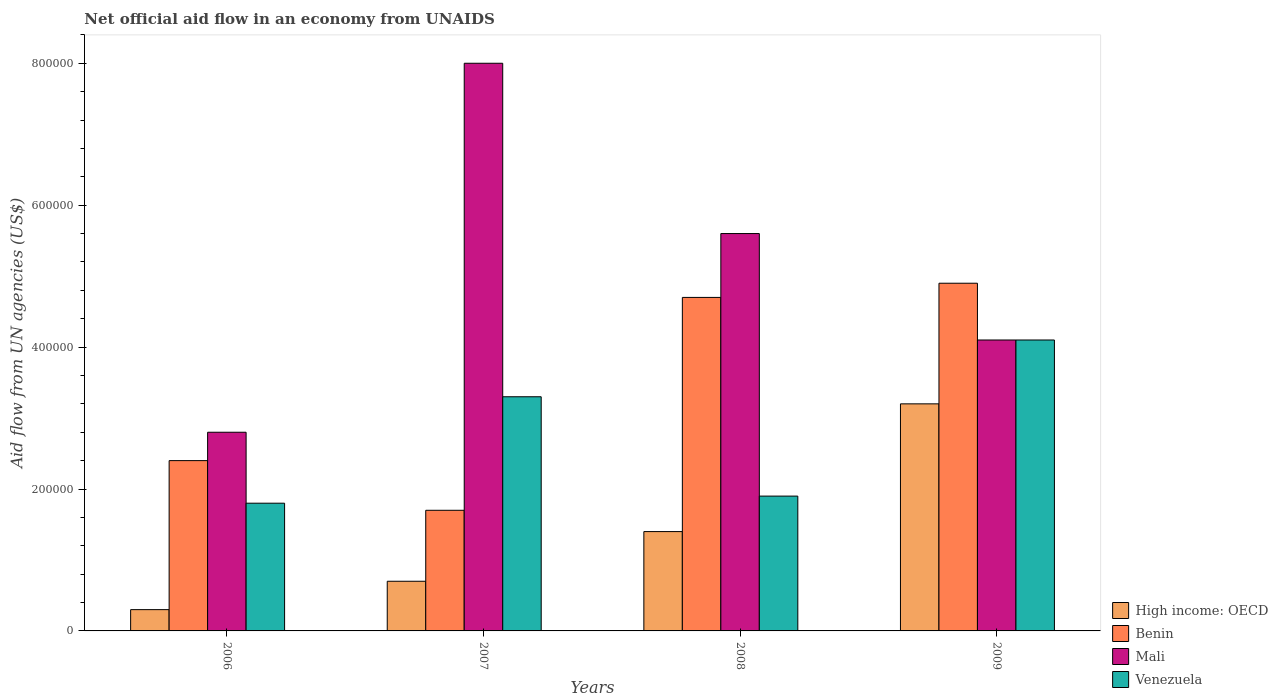How many groups of bars are there?
Keep it short and to the point. 4. Are the number of bars per tick equal to the number of legend labels?
Your answer should be very brief. Yes. How many bars are there on the 3rd tick from the left?
Provide a short and direct response. 4. What is the label of the 1st group of bars from the left?
Give a very brief answer. 2006. In how many cases, is the number of bars for a given year not equal to the number of legend labels?
Your response must be concise. 0. What is the net official aid flow in Venezuela in 2009?
Offer a terse response. 4.10e+05. Across all years, what is the maximum net official aid flow in Venezuela?
Your response must be concise. 4.10e+05. Across all years, what is the minimum net official aid flow in Mali?
Provide a succinct answer. 2.80e+05. In which year was the net official aid flow in Benin maximum?
Give a very brief answer. 2009. In which year was the net official aid flow in Mali minimum?
Make the answer very short. 2006. What is the total net official aid flow in Mali in the graph?
Ensure brevity in your answer.  2.05e+06. What is the difference between the net official aid flow in Benin in 2006 and that in 2009?
Your answer should be very brief. -2.50e+05. What is the difference between the net official aid flow in High income: OECD in 2008 and the net official aid flow in Mali in 2009?
Give a very brief answer. -2.70e+05. What is the average net official aid flow in Venezuela per year?
Offer a very short reply. 2.78e+05. In the year 2009, what is the difference between the net official aid flow in High income: OECD and net official aid flow in Mali?
Ensure brevity in your answer.  -9.00e+04. In how many years, is the net official aid flow in Benin greater than 520000 US$?
Provide a succinct answer. 0. What is the ratio of the net official aid flow in High income: OECD in 2006 to that in 2008?
Give a very brief answer. 0.21. Is the net official aid flow in Venezuela in 2008 less than that in 2009?
Your response must be concise. Yes. What is the difference between the highest and the lowest net official aid flow in High income: OECD?
Provide a succinct answer. 2.90e+05. What does the 4th bar from the left in 2009 represents?
Your answer should be compact. Venezuela. What does the 3rd bar from the right in 2007 represents?
Keep it short and to the point. Benin. Is it the case that in every year, the sum of the net official aid flow in Venezuela and net official aid flow in Mali is greater than the net official aid flow in High income: OECD?
Your answer should be very brief. Yes. What is the difference between two consecutive major ticks on the Y-axis?
Your response must be concise. 2.00e+05. Are the values on the major ticks of Y-axis written in scientific E-notation?
Provide a succinct answer. No. Does the graph contain any zero values?
Keep it short and to the point. No. Where does the legend appear in the graph?
Provide a short and direct response. Bottom right. What is the title of the graph?
Provide a short and direct response. Net official aid flow in an economy from UNAIDS. What is the label or title of the Y-axis?
Offer a very short reply. Aid flow from UN agencies (US$). What is the Aid flow from UN agencies (US$) in Mali in 2006?
Your answer should be very brief. 2.80e+05. What is the Aid flow from UN agencies (US$) of Venezuela in 2006?
Offer a very short reply. 1.80e+05. What is the Aid flow from UN agencies (US$) in High income: OECD in 2007?
Your answer should be compact. 7.00e+04. What is the Aid flow from UN agencies (US$) in Mali in 2007?
Your answer should be very brief. 8.00e+05. What is the Aid flow from UN agencies (US$) of Benin in 2008?
Give a very brief answer. 4.70e+05. What is the Aid flow from UN agencies (US$) in Mali in 2008?
Provide a short and direct response. 5.60e+05. What is the Aid flow from UN agencies (US$) in High income: OECD in 2009?
Keep it short and to the point. 3.20e+05. What is the Aid flow from UN agencies (US$) in Venezuela in 2009?
Provide a short and direct response. 4.10e+05. Across all years, what is the maximum Aid flow from UN agencies (US$) of Benin?
Provide a short and direct response. 4.90e+05. Across all years, what is the minimum Aid flow from UN agencies (US$) in Benin?
Your answer should be compact. 1.70e+05. Across all years, what is the minimum Aid flow from UN agencies (US$) in Mali?
Offer a very short reply. 2.80e+05. What is the total Aid flow from UN agencies (US$) in High income: OECD in the graph?
Provide a succinct answer. 5.60e+05. What is the total Aid flow from UN agencies (US$) in Benin in the graph?
Your answer should be compact. 1.37e+06. What is the total Aid flow from UN agencies (US$) of Mali in the graph?
Provide a short and direct response. 2.05e+06. What is the total Aid flow from UN agencies (US$) of Venezuela in the graph?
Provide a succinct answer. 1.11e+06. What is the difference between the Aid flow from UN agencies (US$) of Mali in 2006 and that in 2007?
Ensure brevity in your answer.  -5.20e+05. What is the difference between the Aid flow from UN agencies (US$) in Benin in 2006 and that in 2008?
Your answer should be very brief. -2.30e+05. What is the difference between the Aid flow from UN agencies (US$) of Mali in 2006 and that in 2008?
Offer a very short reply. -2.80e+05. What is the difference between the Aid flow from UN agencies (US$) in High income: OECD in 2006 and that in 2009?
Ensure brevity in your answer.  -2.90e+05. What is the difference between the Aid flow from UN agencies (US$) in Benin in 2006 and that in 2009?
Your answer should be very brief. -2.50e+05. What is the difference between the Aid flow from UN agencies (US$) of Venezuela in 2007 and that in 2008?
Give a very brief answer. 1.40e+05. What is the difference between the Aid flow from UN agencies (US$) in High income: OECD in 2007 and that in 2009?
Provide a succinct answer. -2.50e+05. What is the difference between the Aid flow from UN agencies (US$) in Benin in 2007 and that in 2009?
Offer a very short reply. -3.20e+05. What is the difference between the Aid flow from UN agencies (US$) in High income: OECD in 2008 and that in 2009?
Your response must be concise. -1.80e+05. What is the difference between the Aid flow from UN agencies (US$) of Benin in 2008 and that in 2009?
Your answer should be very brief. -2.00e+04. What is the difference between the Aid flow from UN agencies (US$) of Venezuela in 2008 and that in 2009?
Offer a very short reply. -2.20e+05. What is the difference between the Aid flow from UN agencies (US$) in High income: OECD in 2006 and the Aid flow from UN agencies (US$) in Benin in 2007?
Ensure brevity in your answer.  -1.40e+05. What is the difference between the Aid flow from UN agencies (US$) of High income: OECD in 2006 and the Aid flow from UN agencies (US$) of Mali in 2007?
Your answer should be very brief. -7.70e+05. What is the difference between the Aid flow from UN agencies (US$) in Benin in 2006 and the Aid flow from UN agencies (US$) in Mali in 2007?
Provide a succinct answer. -5.60e+05. What is the difference between the Aid flow from UN agencies (US$) of High income: OECD in 2006 and the Aid flow from UN agencies (US$) of Benin in 2008?
Your answer should be compact. -4.40e+05. What is the difference between the Aid flow from UN agencies (US$) in High income: OECD in 2006 and the Aid flow from UN agencies (US$) in Mali in 2008?
Give a very brief answer. -5.30e+05. What is the difference between the Aid flow from UN agencies (US$) of Benin in 2006 and the Aid flow from UN agencies (US$) of Mali in 2008?
Provide a short and direct response. -3.20e+05. What is the difference between the Aid flow from UN agencies (US$) in Mali in 2006 and the Aid flow from UN agencies (US$) in Venezuela in 2008?
Your answer should be very brief. 9.00e+04. What is the difference between the Aid flow from UN agencies (US$) of High income: OECD in 2006 and the Aid flow from UN agencies (US$) of Benin in 2009?
Give a very brief answer. -4.60e+05. What is the difference between the Aid flow from UN agencies (US$) in High income: OECD in 2006 and the Aid flow from UN agencies (US$) in Mali in 2009?
Your response must be concise. -3.80e+05. What is the difference between the Aid flow from UN agencies (US$) in High income: OECD in 2006 and the Aid flow from UN agencies (US$) in Venezuela in 2009?
Keep it short and to the point. -3.80e+05. What is the difference between the Aid flow from UN agencies (US$) of Benin in 2006 and the Aid flow from UN agencies (US$) of Mali in 2009?
Keep it short and to the point. -1.70e+05. What is the difference between the Aid flow from UN agencies (US$) of High income: OECD in 2007 and the Aid flow from UN agencies (US$) of Benin in 2008?
Give a very brief answer. -4.00e+05. What is the difference between the Aid flow from UN agencies (US$) in High income: OECD in 2007 and the Aid flow from UN agencies (US$) in Mali in 2008?
Provide a short and direct response. -4.90e+05. What is the difference between the Aid flow from UN agencies (US$) in Benin in 2007 and the Aid flow from UN agencies (US$) in Mali in 2008?
Your answer should be very brief. -3.90e+05. What is the difference between the Aid flow from UN agencies (US$) in Mali in 2007 and the Aid flow from UN agencies (US$) in Venezuela in 2008?
Your response must be concise. 6.10e+05. What is the difference between the Aid flow from UN agencies (US$) in High income: OECD in 2007 and the Aid flow from UN agencies (US$) in Benin in 2009?
Your answer should be very brief. -4.20e+05. What is the difference between the Aid flow from UN agencies (US$) in High income: OECD in 2007 and the Aid flow from UN agencies (US$) in Venezuela in 2009?
Provide a succinct answer. -3.40e+05. What is the difference between the Aid flow from UN agencies (US$) of Mali in 2007 and the Aid flow from UN agencies (US$) of Venezuela in 2009?
Your answer should be very brief. 3.90e+05. What is the difference between the Aid flow from UN agencies (US$) of High income: OECD in 2008 and the Aid flow from UN agencies (US$) of Benin in 2009?
Your answer should be compact. -3.50e+05. What is the difference between the Aid flow from UN agencies (US$) of High income: OECD in 2008 and the Aid flow from UN agencies (US$) of Mali in 2009?
Your answer should be very brief. -2.70e+05. What is the difference between the Aid flow from UN agencies (US$) of High income: OECD in 2008 and the Aid flow from UN agencies (US$) of Venezuela in 2009?
Give a very brief answer. -2.70e+05. What is the difference between the Aid flow from UN agencies (US$) in Benin in 2008 and the Aid flow from UN agencies (US$) in Venezuela in 2009?
Provide a succinct answer. 6.00e+04. What is the average Aid flow from UN agencies (US$) in Benin per year?
Provide a short and direct response. 3.42e+05. What is the average Aid flow from UN agencies (US$) in Mali per year?
Make the answer very short. 5.12e+05. What is the average Aid flow from UN agencies (US$) of Venezuela per year?
Make the answer very short. 2.78e+05. In the year 2006, what is the difference between the Aid flow from UN agencies (US$) in High income: OECD and Aid flow from UN agencies (US$) in Mali?
Offer a very short reply. -2.50e+05. In the year 2006, what is the difference between the Aid flow from UN agencies (US$) in Benin and Aid flow from UN agencies (US$) in Mali?
Ensure brevity in your answer.  -4.00e+04. In the year 2006, what is the difference between the Aid flow from UN agencies (US$) of Benin and Aid flow from UN agencies (US$) of Venezuela?
Keep it short and to the point. 6.00e+04. In the year 2007, what is the difference between the Aid flow from UN agencies (US$) in High income: OECD and Aid flow from UN agencies (US$) in Mali?
Keep it short and to the point. -7.30e+05. In the year 2007, what is the difference between the Aid flow from UN agencies (US$) of Benin and Aid flow from UN agencies (US$) of Mali?
Provide a succinct answer. -6.30e+05. In the year 2007, what is the difference between the Aid flow from UN agencies (US$) of Benin and Aid flow from UN agencies (US$) of Venezuela?
Provide a succinct answer. -1.60e+05. In the year 2007, what is the difference between the Aid flow from UN agencies (US$) in Mali and Aid flow from UN agencies (US$) in Venezuela?
Give a very brief answer. 4.70e+05. In the year 2008, what is the difference between the Aid flow from UN agencies (US$) in High income: OECD and Aid flow from UN agencies (US$) in Benin?
Your answer should be compact. -3.30e+05. In the year 2008, what is the difference between the Aid flow from UN agencies (US$) in High income: OECD and Aid flow from UN agencies (US$) in Mali?
Offer a terse response. -4.20e+05. In the year 2008, what is the difference between the Aid flow from UN agencies (US$) in Benin and Aid flow from UN agencies (US$) in Mali?
Offer a terse response. -9.00e+04. In the year 2008, what is the difference between the Aid flow from UN agencies (US$) in Mali and Aid flow from UN agencies (US$) in Venezuela?
Offer a very short reply. 3.70e+05. In the year 2009, what is the difference between the Aid flow from UN agencies (US$) of High income: OECD and Aid flow from UN agencies (US$) of Benin?
Keep it short and to the point. -1.70e+05. In the year 2009, what is the difference between the Aid flow from UN agencies (US$) of High income: OECD and Aid flow from UN agencies (US$) of Venezuela?
Keep it short and to the point. -9.00e+04. What is the ratio of the Aid flow from UN agencies (US$) of High income: OECD in 2006 to that in 2007?
Provide a succinct answer. 0.43. What is the ratio of the Aid flow from UN agencies (US$) of Benin in 2006 to that in 2007?
Your answer should be very brief. 1.41. What is the ratio of the Aid flow from UN agencies (US$) of Venezuela in 2006 to that in 2007?
Your answer should be compact. 0.55. What is the ratio of the Aid flow from UN agencies (US$) in High income: OECD in 2006 to that in 2008?
Ensure brevity in your answer.  0.21. What is the ratio of the Aid flow from UN agencies (US$) in Benin in 2006 to that in 2008?
Offer a terse response. 0.51. What is the ratio of the Aid flow from UN agencies (US$) in Mali in 2006 to that in 2008?
Offer a terse response. 0.5. What is the ratio of the Aid flow from UN agencies (US$) in High income: OECD in 2006 to that in 2009?
Your response must be concise. 0.09. What is the ratio of the Aid flow from UN agencies (US$) of Benin in 2006 to that in 2009?
Offer a terse response. 0.49. What is the ratio of the Aid flow from UN agencies (US$) of Mali in 2006 to that in 2009?
Offer a terse response. 0.68. What is the ratio of the Aid flow from UN agencies (US$) of Venezuela in 2006 to that in 2009?
Provide a succinct answer. 0.44. What is the ratio of the Aid flow from UN agencies (US$) in High income: OECD in 2007 to that in 2008?
Offer a terse response. 0.5. What is the ratio of the Aid flow from UN agencies (US$) of Benin in 2007 to that in 2008?
Your response must be concise. 0.36. What is the ratio of the Aid flow from UN agencies (US$) of Mali in 2007 to that in 2008?
Your answer should be very brief. 1.43. What is the ratio of the Aid flow from UN agencies (US$) in Venezuela in 2007 to that in 2008?
Provide a succinct answer. 1.74. What is the ratio of the Aid flow from UN agencies (US$) in High income: OECD in 2007 to that in 2009?
Keep it short and to the point. 0.22. What is the ratio of the Aid flow from UN agencies (US$) in Benin in 2007 to that in 2009?
Your answer should be compact. 0.35. What is the ratio of the Aid flow from UN agencies (US$) in Mali in 2007 to that in 2009?
Make the answer very short. 1.95. What is the ratio of the Aid flow from UN agencies (US$) in Venezuela in 2007 to that in 2009?
Make the answer very short. 0.8. What is the ratio of the Aid flow from UN agencies (US$) of High income: OECD in 2008 to that in 2009?
Your answer should be very brief. 0.44. What is the ratio of the Aid flow from UN agencies (US$) of Benin in 2008 to that in 2009?
Your response must be concise. 0.96. What is the ratio of the Aid flow from UN agencies (US$) of Mali in 2008 to that in 2009?
Keep it short and to the point. 1.37. What is the ratio of the Aid flow from UN agencies (US$) of Venezuela in 2008 to that in 2009?
Your response must be concise. 0.46. What is the difference between the highest and the second highest Aid flow from UN agencies (US$) in High income: OECD?
Offer a terse response. 1.80e+05. What is the difference between the highest and the second highest Aid flow from UN agencies (US$) of Benin?
Offer a very short reply. 2.00e+04. What is the difference between the highest and the second highest Aid flow from UN agencies (US$) in Venezuela?
Give a very brief answer. 8.00e+04. What is the difference between the highest and the lowest Aid flow from UN agencies (US$) in High income: OECD?
Offer a terse response. 2.90e+05. What is the difference between the highest and the lowest Aid flow from UN agencies (US$) in Benin?
Provide a succinct answer. 3.20e+05. What is the difference between the highest and the lowest Aid flow from UN agencies (US$) of Mali?
Provide a succinct answer. 5.20e+05. What is the difference between the highest and the lowest Aid flow from UN agencies (US$) of Venezuela?
Keep it short and to the point. 2.30e+05. 